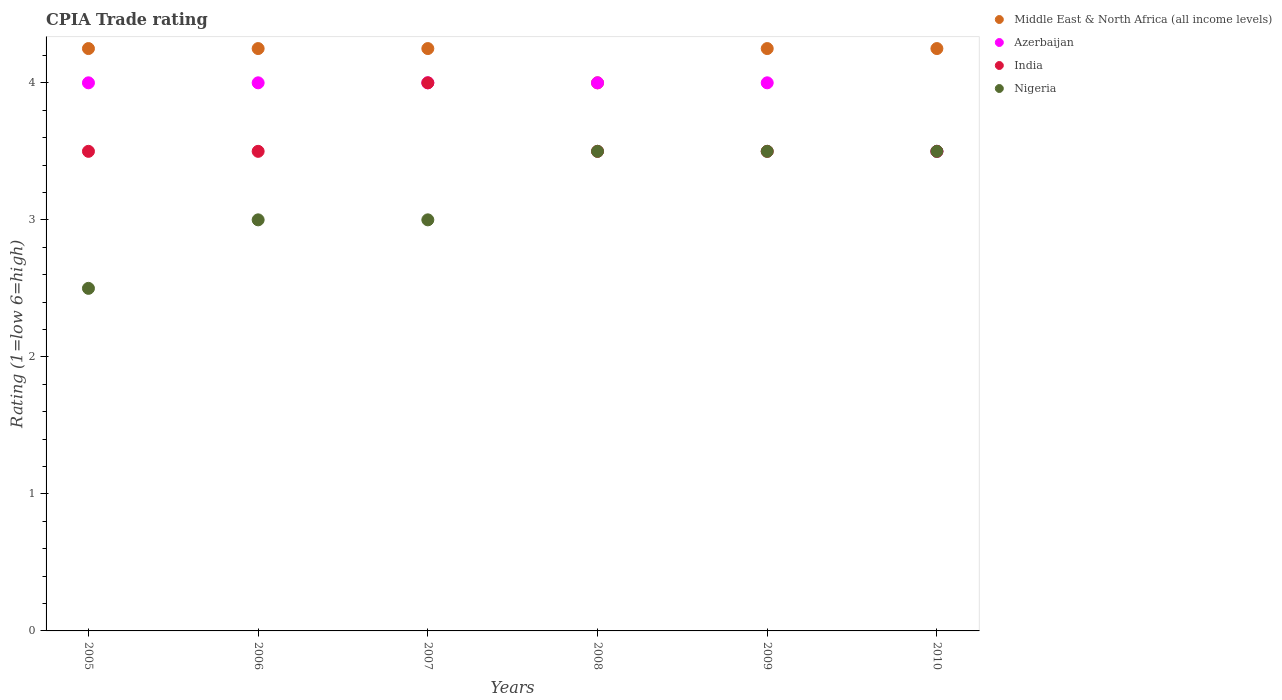How many different coloured dotlines are there?
Make the answer very short. 4. What is the CPIA rating in Middle East & North Africa (all income levels) in 2005?
Your answer should be compact. 4.25. Across all years, what is the maximum CPIA rating in Middle East & North Africa (all income levels)?
Provide a short and direct response. 4.25. In which year was the CPIA rating in Azerbaijan minimum?
Your response must be concise. 2010. What is the difference between the CPIA rating in India in 2007 and the CPIA rating in Nigeria in 2008?
Your answer should be very brief. 0.5. What is the average CPIA rating in Nigeria per year?
Your answer should be compact. 3.17. In how many years, is the CPIA rating in Nigeria greater than 3.8?
Ensure brevity in your answer.  0. What is the ratio of the CPIA rating in Middle East & North Africa (all income levels) in 2007 to that in 2008?
Make the answer very short. 1.06. Is the difference between the CPIA rating in Azerbaijan in 2005 and 2007 greater than the difference between the CPIA rating in Nigeria in 2005 and 2007?
Your response must be concise. Yes. What is the difference between the highest and the second highest CPIA rating in Nigeria?
Ensure brevity in your answer.  0. In how many years, is the CPIA rating in Middle East & North Africa (all income levels) greater than the average CPIA rating in Middle East & North Africa (all income levels) taken over all years?
Make the answer very short. 5. Is the sum of the CPIA rating in Azerbaijan in 2005 and 2010 greater than the maximum CPIA rating in Middle East & North Africa (all income levels) across all years?
Provide a succinct answer. Yes. Is it the case that in every year, the sum of the CPIA rating in Nigeria and CPIA rating in Middle East & North Africa (all income levels)  is greater than the sum of CPIA rating in India and CPIA rating in Azerbaijan?
Provide a succinct answer. Yes. Is it the case that in every year, the sum of the CPIA rating in Nigeria and CPIA rating in Azerbaijan  is greater than the CPIA rating in India?
Offer a very short reply. Yes. Is the CPIA rating in Azerbaijan strictly less than the CPIA rating in India over the years?
Offer a very short reply. No. How many dotlines are there?
Keep it short and to the point. 4. Are the values on the major ticks of Y-axis written in scientific E-notation?
Make the answer very short. No. Does the graph contain grids?
Offer a very short reply. No. Where does the legend appear in the graph?
Your response must be concise. Top right. How many legend labels are there?
Provide a short and direct response. 4. What is the title of the graph?
Provide a succinct answer. CPIA Trade rating. What is the label or title of the Y-axis?
Offer a terse response. Rating (1=low 6=high). What is the Rating (1=low 6=high) of Middle East & North Africa (all income levels) in 2005?
Provide a short and direct response. 4.25. What is the Rating (1=low 6=high) of Azerbaijan in 2005?
Your response must be concise. 4. What is the Rating (1=low 6=high) of India in 2005?
Make the answer very short. 3.5. What is the Rating (1=low 6=high) of Middle East & North Africa (all income levels) in 2006?
Ensure brevity in your answer.  4.25. What is the Rating (1=low 6=high) of Azerbaijan in 2006?
Provide a succinct answer. 4. What is the Rating (1=low 6=high) of Nigeria in 2006?
Make the answer very short. 3. What is the Rating (1=low 6=high) in Middle East & North Africa (all income levels) in 2007?
Make the answer very short. 4.25. What is the Rating (1=low 6=high) of India in 2007?
Give a very brief answer. 4. What is the Rating (1=low 6=high) of India in 2008?
Make the answer very short. 3.5. What is the Rating (1=low 6=high) in Middle East & North Africa (all income levels) in 2009?
Ensure brevity in your answer.  4.25. What is the Rating (1=low 6=high) in Azerbaijan in 2009?
Provide a succinct answer. 4. What is the Rating (1=low 6=high) in Nigeria in 2009?
Provide a succinct answer. 3.5. What is the Rating (1=low 6=high) of Middle East & North Africa (all income levels) in 2010?
Offer a terse response. 4.25. What is the Rating (1=low 6=high) of Azerbaijan in 2010?
Your answer should be compact. 3.5. What is the Rating (1=low 6=high) in India in 2010?
Keep it short and to the point. 3.5. Across all years, what is the maximum Rating (1=low 6=high) of Middle East & North Africa (all income levels)?
Offer a terse response. 4.25. Across all years, what is the maximum Rating (1=low 6=high) in Nigeria?
Ensure brevity in your answer.  3.5. Across all years, what is the minimum Rating (1=low 6=high) in Middle East & North Africa (all income levels)?
Your answer should be very brief. 4. Across all years, what is the minimum Rating (1=low 6=high) of Azerbaijan?
Offer a very short reply. 3.5. Across all years, what is the minimum Rating (1=low 6=high) in Nigeria?
Your answer should be compact. 2.5. What is the total Rating (1=low 6=high) in Middle East & North Africa (all income levels) in the graph?
Your answer should be compact. 25.25. What is the total Rating (1=low 6=high) of India in the graph?
Offer a terse response. 21.5. What is the difference between the Rating (1=low 6=high) of Azerbaijan in 2005 and that in 2006?
Give a very brief answer. 0. What is the difference between the Rating (1=low 6=high) in India in 2005 and that in 2006?
Offer a very short reply. 0. What is the difference between the Rating (1=low 6=high) in Nigeria in 2005 and that in 2006?
Your response must be concise. -0.5. What is the difference between the Rating (1=low 6=high) in Azerbaijan in 2005 and that in 2007?
Keep it short and to the point. 0. What is the difference between the Rating (1=low 6=high) of Nigeria in 2005 and that in 2007?
Your answer should be compact. -0.5. What is the difference between the Rating (1=low 6=high) of Middle East & North Africa (all income levels) in 2005 and that in 2008?
Provide a short and direct response. 0.25. What is the difference between the Rating (1=low 6=high) in Azerbaijan in 2005 and that in 2008?
Give a very brief answer. 0. What is the difference between the Rating (1=low 6=high) of Nigeria in 2005 and that in 2008?
Offer a very short reply. -1. What is the difference between the Rating (1=low 6=high) of Middle East & North Africa (all income levels) in 2005 and that in 2010?
Offer a very short reply. 0. What is the difference between the Rating (1=low 6=high) of Nigeria in 2005 and that in 2010?
Ensure brevity in your answer.  -1. What is the difference between the Rating (1=low 6=high) of Azerbaijan in 2006 and that in 2007?
Provide a succinct answer. 0. What is the difference between the Rating (1=low 6=high) in Middle East & North Africa (all income levels) in 2006 and that in 2008?
Your answer should be very brief. 0.25. What is the difference between the Rating (1=low 6=high) of Azerbaijan in 2006 and that in 2008?
Your answer should be very brief. 0. What is the difference between the Rating (1=low 6=high) in India in 2006 and that in 2008?
Offer a terse response. 0. What is the difference between the Rating (1=low 6=high) in Nigeria in 2006 and that in 2008?
Make the answer very short. -0.5. What is the difference between the Rating (1=low 6=high) in Middle East & North Africa (all income levels) in 2006 and that in 2009?
Offer a very short reply. 0. What is the difference between the Rating (1=low 6=high) of India in 2006 and that in 2009?
Keep it short and to the point. 0. What is the difference between the Rating (1=low 6=high) in Nigeria in 2006 and that in 2009?
Offer a very short reply. -0.5. What is the difference between the Rating (1=low 6=high) of Azerbaijan in 2006 and that in 2010?
Your response must be concise. 0.5. What is the difference between the Rating (1=low 6=high) in Nigeria in 2007 and that in 2008?
Your response must be concise. -0.5. What is the difference between the Rating (1=low 6=high) in India in 2007 and that in 2009?
Your response must be concise. 0.5. What is the difference between the Rating (1=low 6=high) of Middle East & North Africa (all income levels) in 2007 and that in 2010?
Provide a succinct answer. 0. What is the difference between the Rating (1=low 6=high) of Azerbaijan in 2007 and that in 2010?
Offer a very short reply. 0.5. What is the difference between the Rating (1=low 6=high) in India in 2007 and that in 2010?
Give a very brief answer. 0.5. What is the difference between the Rating (1=low 6=high) in India in 2008 and that in 2009?
Keep it short and to the point. 0. What is the difference between the Rating (1=low 6=high) of Azerbaijan in 2008 and that in 2010?
Your answer should be compact. 0.5. What is the difference between the Rating (1=low 6=high) of India in 2008 and that in 2010?
Your answer should be very brief. 0. What is the difference between the Rating (1=low 6=high) in Nigeria in 2008 and that in 2010?
Ensure brevity in your answer.  0. What is the difference between the Rating (1=low 6=high) in Middle East & North Africa (all income levels) in 2009 and that in 2010?
Your answer should be very brief. 0. What is the difference between the Rating (1=low 6=high) in India in 2009 and that in 2010?
Make the answer very short. 0. What is the difference between the Rating (1=low 6=high) of Middle East & North Africa (all income levels) in 2005 and the Rating (1=low 6=high) of Azerbaijan in 2006?
Your response must be concise. 0.25. What is the difference between the Rating (1=low 6=high) in Middle East & North Africa (all income levels) in 2005 and the Rating (1=low 6=high) in India in 2006?
Give a very brief answer. 0.75. What is the difference between the Rating (1=low 6=high) of India in 2005 and the Rating (1=low 6=high) of Nigeria in 2006?
Your answer should be compact. 0.5. What is the difference between the Rating (1=low 6=high) in Middle East & North Africa (all income levels) in 2005 and the Rating (1=low 6=high) in Azerbaijan in 2007?
Provide a short and direct response. 0.25. What is the difference between the Rating (1=low 6=high) in Middle East & North Africa (all income levels) in 2005 and the Rating (1=low 6=high) in India in 2007?
Keep it short and to the point. 0.25. What is the difference between the Rating (1=low 6=high) of Azerbaijan in 2005 and the Rating (1=low 6=high) of Nigeria in 2007?
Ensure brevity in your answer.  1. What is the difference between the Rating (1=low 6=high) of Middle East & North Africa (all income levels) in 2005 and the Rating (1=low 6=high) of Azerbaijan in 2008?
Make the answer very short. 0.25. What is the difference between the Rating (1=low 6=high) in Middle East & North Africa (all income levels) in 2005 and the Rating (1=low 6=high) in India in 2008?
Keep it short and to the point. 0.75. What is the difference between the Rating (1=low 6=high) in Azerbaijan in 2005 and the Rating (1=low 6=high) in Nigeria in 2008?
Ensure brevity in your answer.  0.5. What is the difference between the Rating (1=low 6=high) of India in 2005 and the Rating (1=low 6=high) of Nigeria in 2008?
Give a very brief answer. 0. What is the difference between the Rating (1=low 6=high) of Middle East & North Africa (all income levels) in 2005 and the Rating (1=low 6=high) of India in 2009?
Offer a very short reply. 0.75. What is the difference between the Rating (1=low 6=high) of Middle East & North Africa (all income levels) in 2005 and the Rating (1=low 6=high) of Nigeria in 2009?
Your answer should be very brief. 0.75. What is the difference between the Rating (1=low 6=high) of Azerbaijan in 2005 and the Rating (1=low 6=high) of Nigeria in 2009?
Your answer should be compact. 0.5. What is the difference between the Rating (1=low 6=high) in Middle East & North Africa (all income levels) in 2005 and the Rating (1=low 6=high) in Azerbaijan in 2010?
Make the answer very short. 0.75. What is the difference between the Rating (1=low 6=high) in Middle East & North Africa (all income levels) in 2005 and the Rating (1=low 6=high) in Nigeria in 2010?
Your response must be concise. 0.75. What is the difference between the Rating (1=low 6=high) of Azerbaijan in 2005 and the Rating (1=low 6=high) of India in 2010?
Your response must be concise. 0.5. What is the difference between the Rating (1=low 6=high) in Middle East & North Africa (all income levels) in 2006 and the Rating (1=low 6=high) in Nigeria in 2007?
Offer a very short reply. 1.25. What is the difference between the Rating (1=low 6=high) of Azerbaijan in 2006 and the Rating (1=low 6=high) of India in 2007?
Your answer should be compact. 0. What is the difference between the Rating (1=low 6=high) of Azerbaijan in 2006 and the Rating (1=low 6=high) of Nigeria in 2007?
Provide a succinct answer. 1. What is the difference between the Rating (1=low 6=high) of Middle East & North Africa (all income levels) in 2006 and the Rating (1=low 6=high) of India in 2008?
Provide a short and direct response. 0.75. What is the difference between the Rating (1=low 6=high) in Middle East & North Africa (all income levels) in 2006 and the Rating (1=low 6=high) in Nigeria in 2008?
Offer a very short reply. 0.75. What is the difference between the Rating (1=low 6=high) of Azerbaijan in 2006 and the Rating (1=low 6=high) of India in 2008?
Offer a terse response. 0.5. What is the difference between the Rating (1=low 6=high) in Azerbaijan in 2006 and the Rating (1=low 6=high) in Nigeria in 2008?
Your answer should be compact. 0.5. What is the difference between the Rating (1=low 6=high) of India in 2006 and the Rating (1=low 6=high) of Nigeria in 2008?
Offer a terse response. 0. What is the difference between the Rating (1=low 6=high) in Middle East & North Africa (all income levels) in 2006 and the Rating (1=low 6=high) in India in 2009?
Give a very brief answer. 0.75. What is the difference between the Rating (1=low 6=high) of Azerbaijan in 2006 and the Rating (1=low 6=high) of Nigeria in 2009?
Provide a short and direct response. 0.5. What is the difference between the Rating (1=low 6=high) of India in 2006 and the Rating (1=low 6=high) of Nigeria in 2009?
Keep it short and to the point. 0. What is the difference between the Rating (1=low 6=high) in Middle East & North Africa (all income levels) in 2006 and the Rating (1=low 6=high) in India in 2010?
Give a very brief answer. 0.75. What is the difference between the Rating (1=low 6=high) in Middle East & North Africa (all income levels) in 2006 and the Rating (1=low 6=high) in Nigeria in 2010?
Provide a short and direct response. 0.75. What is the difference between the Rating (1=low 6=high) in Azerbaijan in 2006 and the Rating (1=low 6=high) in India in 2010?
Make the answer very short. 0.5. What is the difference between the Rating (1=low 6=high) of Azerbaijan in 2006 and the Rating (1=low 6=high) of Nigeria in 2010?
Provide a succinct answer. 0.5. What is the difference between the Rating (1=low 6=high) of Middle East & North Africa (all income levels) in 2007 and the Rating (1=low 6=high) of Azerbaijan in 2008?
Keep it short and to the point. 0.25. What is the difference between the Rating (1=low 6=high) in Middle East & North Africa (all income levels) in 2007 and the Rating (1=low 6=high) in India in 2008?
Give a very brief answer. 0.75. What is the difference between the Rating (1=low 6=high) in Middle East & North Africa (all income levels) in 2007 and the Rating (1=low 6=high) in Nigeria in 2008?
Your answer should be very brief. 0.75. What is the difference between the Rating (1=low 6=high) in Azerbaijan in 2007 and the Rating (1=low 6=high) in India in 2008?
Give a very brief answer. 0.5. What is the difference between the Rating (1=low 6=high) of India in 2007 and the Rating (1=low 6=high) of Nigeria in 2008?
Provide a short and direct response. 0.5. What is the difference between the Rating (1=low 6=high) of Middle East & North Africa (all income levels) in 2007 and the Rating (1=low 6=high) of Nigeria in 2009?
Provide a short and direct response. 0.75. What is the difference between the Rating (1=low 6=high) in Azerbaijan in 2007 and the Rating (1=low 6=high) in India in 2009?
Offer a very short reply. 0.5. What is the difference between the Rating (1=low 6=high) of Azerbaijan in 2007 and the Rating (1=low 6=high) of Nigeria in 2009?
Offer a terse response. 0.5. What is the difference between the Rating (1=low 6=high) in India in 2007 and the Rating (1=low 6=high) in Nigeria in 2009?
Offer a very short reply. 0.5. What is the difference between the Rating (1=low 6=high) of Middle East & North Africa (all income levels) in 2007 and the Rating (1=low 6=high) of Azerbaijan in 2010?
Ensure brevity in your answer.  0.75. What is the difference between the Rating (1=low 6=high) of Azerbaijan in 2007 and the Rating (1=low 6=high) of India in 2010?
Your answer should be very brief. 0.5. What is the difference between the Rating (1=low 6=high) of Middle East & North Africa (all income levels) in 2008 and the Rating (1=low 6=high) of India in 2009?
Your response must be concise. 0.5. What is the difference between the Rating (1=low 6=high) of Middle East & North Africa (all income levels) in 2008 and the Rating (1=low 6=high) of Nigeria in 2009?
Your response must be concise. 0.5. What is the difference between the Rating (1=low 6=high) of Azerbaijan in 2008 and the Rating (1=low 6=high) of India in 2009?
Offer a terse response. 0.5. What is the difference between the Rating (1=low 6=high) in Azerbaijan in 2008 and the Rating (1=low 6=high) in Nigeria in 2009?
Your response must be concise. 0.5. What is the difference between the Rating (1=low 6=high) in India in 2008 and the Rating (1=low 6=high) in Nigeria in 2009?
Keep it short and to the point. 0. What is the difference between the Rating (1=low 6=high) of Middle East & North Africa (all income levels) in 2008 and the Rating (1=low 6=high) of Azerbaijan in 2010?
Keep it short and to the point. 0.5. What is the difference between the Rating (1=low 6=high) in Middle East & North Africa (all income levels) in 2008 and the Rating (1=low 6=high) in India in 2010?
Give a very brief answer. 0.5. What is the difference between the Rating (1=low 6=high) in Azerbaijan in 2008 and the Rating (1=low 6=high) in India in 2010?
Your answer should be compact. 0.5. What is the difference between the Rating (1=low 6=high) in Middle East & North Africa (all income levels) in 2009 and the Rating (1=low 6=high) in Azerbaijan in 2010?
Provide a short and direct response. 0.75. What is the difference between the Rating (1=low 6=high) of Middle East & North Africa (all income levels) in 2009 and the Rating (1=low 6=high) of India in 2010?
Keep it short and to the point. 0.75. What is the difference between the Rating (1=low 6=high) in Middle East & North Africa (all income levels) in 2009 and the Rating (1=low 6=high) in Nigeria in 2010?
Ensure brevity in your answer.  0.75. What is the difference between the Rating (1=low 6=high) of Azerbaijan in 2009 and the Rating (1=low 6=high) of India in 2010?
Keep it short and to the point. 0.5. What is the average Rating (1=low 6=high) in Middle East & North Africa (all income levels) per year?
Offer a terse response. 4.21. What is the average Rating (1=low 6=high) in Azerbaijan per year?
Ensure brevity in your answer.  3.92. What is the average Rating (1=low 6=high) of India per year?
Provide a short and direct response. 3.58. What is the average Rating (1=low 6=high) in Nigeria per year?
Offer a very short reply. 3.17. In the year 2005, what is the difference between the Rating (1=low 6=high) of Middle East & North Africa (all income levels) and Rating (1=low 6=high) of Azerbaijan?
Your answer should be compact. 0.25. In the year 2005, what is the difference between the Rating (1=low 6=high) in Middle East & North Africa (all income levels) and Rating (1=low 6=high) in Nigeria?
Provide a short and direct response. 1.75. In the year 2005, what is the difference between the Rating (1=low 6=high) of Azerbaijan and Rating (1=low 6=high) of India?
Provide a short and direct response. 0.5. In the year 2005, what is the difference between the Rating (1=low 6=high) in India and Rating (1=low 6=high) in Nigeria?
Offer a very short reply. 1. In the year 2006, what is the difference between the Rating (1=low 6=high) in Middle East & North Africa (all income levels) and Rating (1=low 6=high) in Azerbaijan?
Your answer should be compact. 0.25. In the year 2006, what is the difference between the Rating (1=low 6=high) of Middle East & North Africa (all income levels) and Rating (1=low 6=high) of Nigeria?
Provide a succinct answer. 1.25. In the year 2006, what is the difference between the Rating (1=low 6=high) in Azerbaijan and Rating (1=low 6=high) in India?
Keep it short and to the point. 0.5. In the year 2006, what is the difference between the Rating (1=low 6=high) in India and Rating (1=low 6=high) in Nigeria?
Your answer should be very brief. 0.5. In the year 2007, what is the difference between the Rating (1=low 6=high) of Middle East & North Africa (all income levels) and Rating (1=low 6=high) of Azerbaijan?
Your answer should be compact. 0.25. In the year 2007, what is the difference between the Rating (1=low 6=high) of Middle East & North Africa (all income levels) and Rating (1=low 6=high) of India?
Keep it short and to the point. 0.25. In the year 2008, what is the difference between the Rating (1=low 6=high) of Middle East & North Africa (all income levels) and Rating (1=low 6=high) of Azerbaijan?
Offer a terse response. 0. In the year 2010, what is the difference between the Rating (1=low 6=high) of Middle East & North Africa (all income levels) and Rating (1=low 6=high) of Nigeria?
Offer a terse response. 0.75. In the year 2010, what is the difference between the Rating (1=low 6=high) of Azerbaijan and Rating (1=low 6=high) of India?
Give a very brief answer. 0. In the year 2010, what is the difference between the Rating (1=low 6=high) in Azerbaijan and Rating (1=low 6=high) in Nigeria?
Give a very brief answer. 0. What is the ratio of the Rating (1=low 6=high) in Middle East & North Africa (all income levels) in 2005 to that in 2006?
Keep it short and to the point. 1. What is the ratio of the Rating (1=low 6=high) of Azerbaijan in 2005 to that in 2007?
Make the answer very short. 1. What is the ratio of the Rating (1=low 6=high) of India in 2005 to that in 2007?
Your answer should be very brief. 0.88. What is the ratio of the Rating (1=low 6=high) of Azerbaijan in 2005 to that in 2008?
Ensure brevity in your answer.  1. What is the ratio of the Rating (1=low 6=high) of Middle East & North Africa (all income levels) in 2005 to that in 2009?
Your response must be concise. 1. What is the ratio of the Rating (1=low 6=high) in Azerbaijan in 2005 to that in 2009?
Your response must be concise. 1. What is the ratio of the Rating (1=low 6=high) of India in 2005 to that in 2009?
Offer a terse response. 1. What is the ratio of the Rating (1=low 6=high) of Azerbaijan in 2005 to that in 2010?
Provide a succinct answer. 1.14. What is the ratio of the Rating (1=low 6=high) in India in 2005 to that in 2010?
Make the answer very short. 1. What is the ratio of the Rating (1=low 6=high) in Nigeria in 2005 to that in 2010?
Offer a terse response. 0.71. What is the ratio of the Rating (1=low 6=high) in Middle East & North Africa (all income levels) in 2006 to that in 2007?
Give a very brief answer. 1. What is the ratio of the Rating (1=low 6=high) of India in 2006 to that in 2007?
Offer a terse response. 0.88. What is the ratio of the Rating (1=low 6=high) of Nigeria in 2006 to that in 2007?
Make the answer very short. 1. What is the ratio of the Rating (1=low 6=high) in Middle East & North Africa (all income levels) in 2006 to that in 2008?
Your answer should be compact. 1.06. What is the ratio of the Rating (1=low 6=high) of Azerbaijan in 2006 to that in 2009?
Ensure brevity in your answer.  1. What is the ratio of the Rating (1=low 6=high) of Azerbaijan in 2006 to that in 2010?
Your answer should be compact. 1.14. What is the ratio of the Rating (1=low 6=high) in Middle East & North Africa (all income levels) in 2007 to that in 2008?
Your answer should be very brief. 1.06. What is the ratio of the Rating (1=low 6=high) in Azerbaijan in 2007 to that in 2008?
Ensure brevity in your answer.  1. What is the ratio of the Rating (1=low 6=high) of Middle East & North Africa (all income levels) in 2007 to that in 2009?
Provide a short and direct response. 1. What is the ratio of the Rating (1=low 6=high) of Azerbaijan in 2007 to that in 2009?
Your response must be concise. 1. What is the ratio of the Rating (1=low 6=high) in India in 2007 to that in 2009?
Your response must be concise. 1.14. What is the ratio of the Rating (1=low 6=high) of Nigeria in 2007 to that in 2009?
Give a very brief answer. 0.86. What is the ratio of the Rating (1=low 6=high) in Azerbaijan in 2007 to that in 2010?
Your answer should be very brief. 1.14. What is the ratio of the Rating (1=low 6=high) in India in 2007 to that in 2010?
Offer a terse response. 1.14. What is the ratio of the Rating (1=low 6=high) of Nigeria in 2007 to that in 2010?
Your answer should be very brief. 0.86. What is the ratio of the Rating (1=low 6=high) in India in 2008 to that in 2009?
Provide a succinct answer. 1. What is the ratio of the Rating (1=low 6=high) in Nigeria in 2008 to that in 2009?
Ensure brevity in your answer.  1. What is the ratio of the Rating (1=low 6=high) in Azerbaijan in 2008 to that in 2010?
Give a very brief answer. 1.14. What is the ratio of the Rating (1=low 6=high) in India in 2008 to that in 2010?
Your answer should be very brief. 1. What is the ratio of the Rating (1=low 6=high) of Middle East & North Africa (all income levels) in 2009 to that in 2010?
Provide a short and direct response. 1. What is the ratio of the Rating (1=low 6=high) in Azerbaijan in 2009 to that in 2010?
Offer a very short reply. 1.14. What is the ratio of the Rating (1=low 6=high) in India in 2009 to that in 2010?
Provide a short and direct response. 1. What is the ratio of the Rating (1=low 6=high) in Nigeria in 2009 to that in 2010?
Ensure brevity in your answer.  1. What is the difference between the highest and the second highest Rating (1=low 6=high) of Middle East & North Africa (all income levels)?
Provide a succinct answer. 0. What is the difference between the highest and the second highest Rating (1=low 6=high) in Nigeria?
Provide a short and direct response. 0. What is the difference between the highest and the lowest Rating (1=low 6=high) of Middle East & North Africa (all income levels)?
Your response must be concise. 0.25. What is the difference between the highest and the lowest Rating (1=low 6=high) of Azerbaijan?
Offer a terse response. 0.5. 